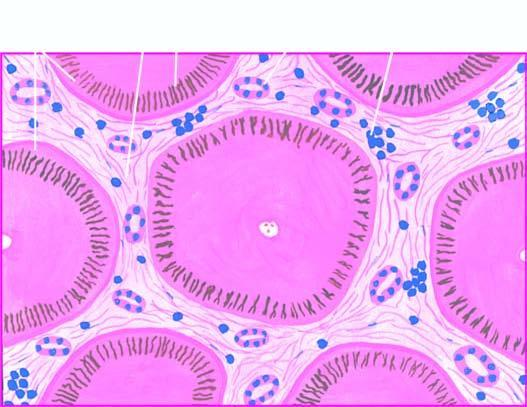re there fibrous scars dividing the hepatic parenchyma into the micronodules?
Answer the question using a single word or phrase. Yes 